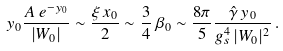Convert formula to latex. <formula><loc_0><loc_0><loc_500><loc_500>y _ { 0 } \frac { A \, e ^ { - y _ { 0 } } } { | W _ { 0 } | } \sim \frac { \xi \, x _ { 0 } } { 2 } \sim \frac { 3 } { 4 } \, \beta _ { 0 } \sim \frac { 8 \pi } { 5 } \frac { \hat { \gamma } \, y _ { 0 } } { g _ { s } ^ { 4 } \, | W _ { 0 } | ^ { 2 } } \, .</formula> 